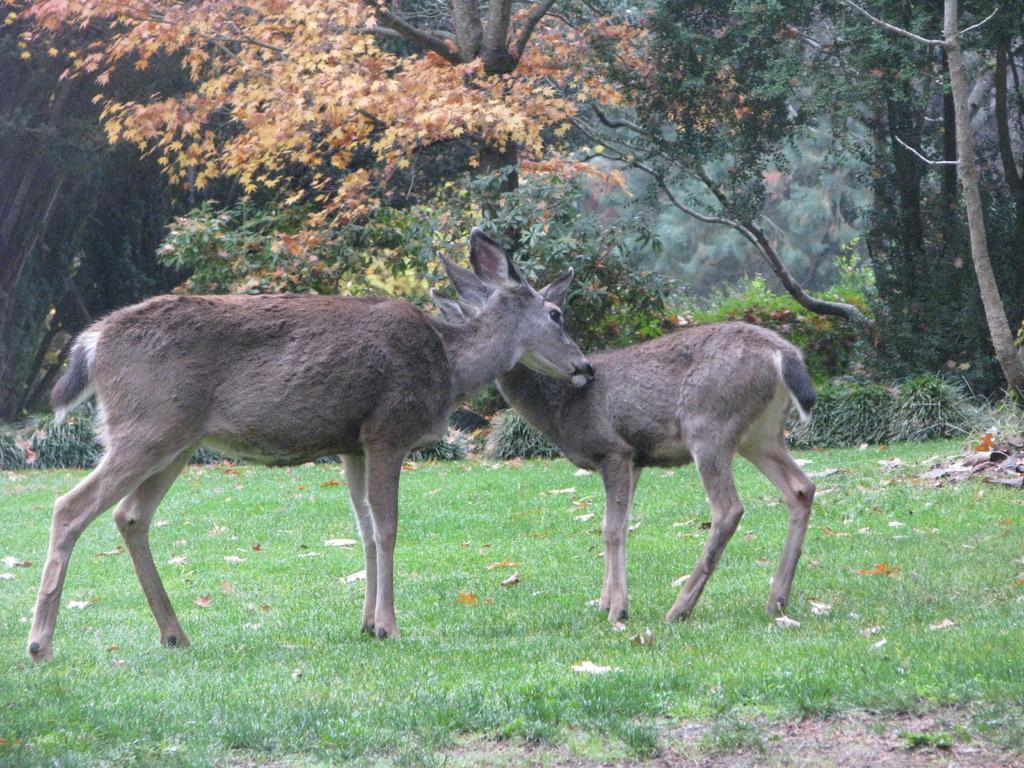In one or two sentences, can you explain what this image depicts? In the picture I can see animals are standing on the ground. In the background I can see trees and the grass. 